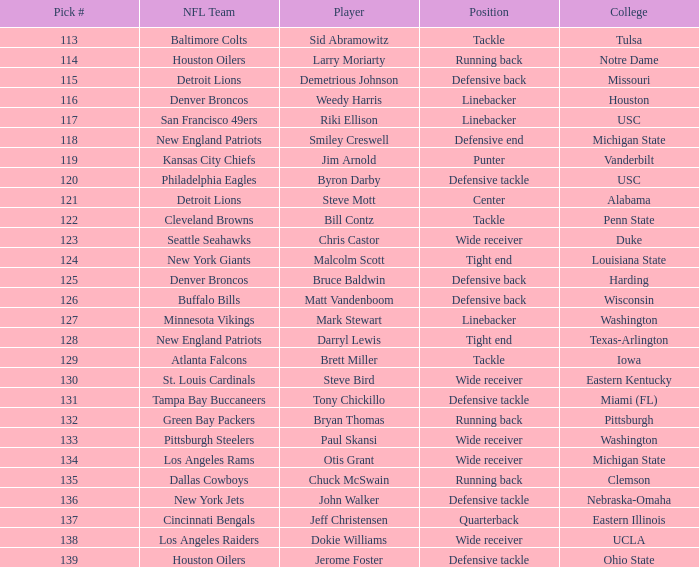How many individuals were chosen by the philadelphia eagles as players? 1.0. 